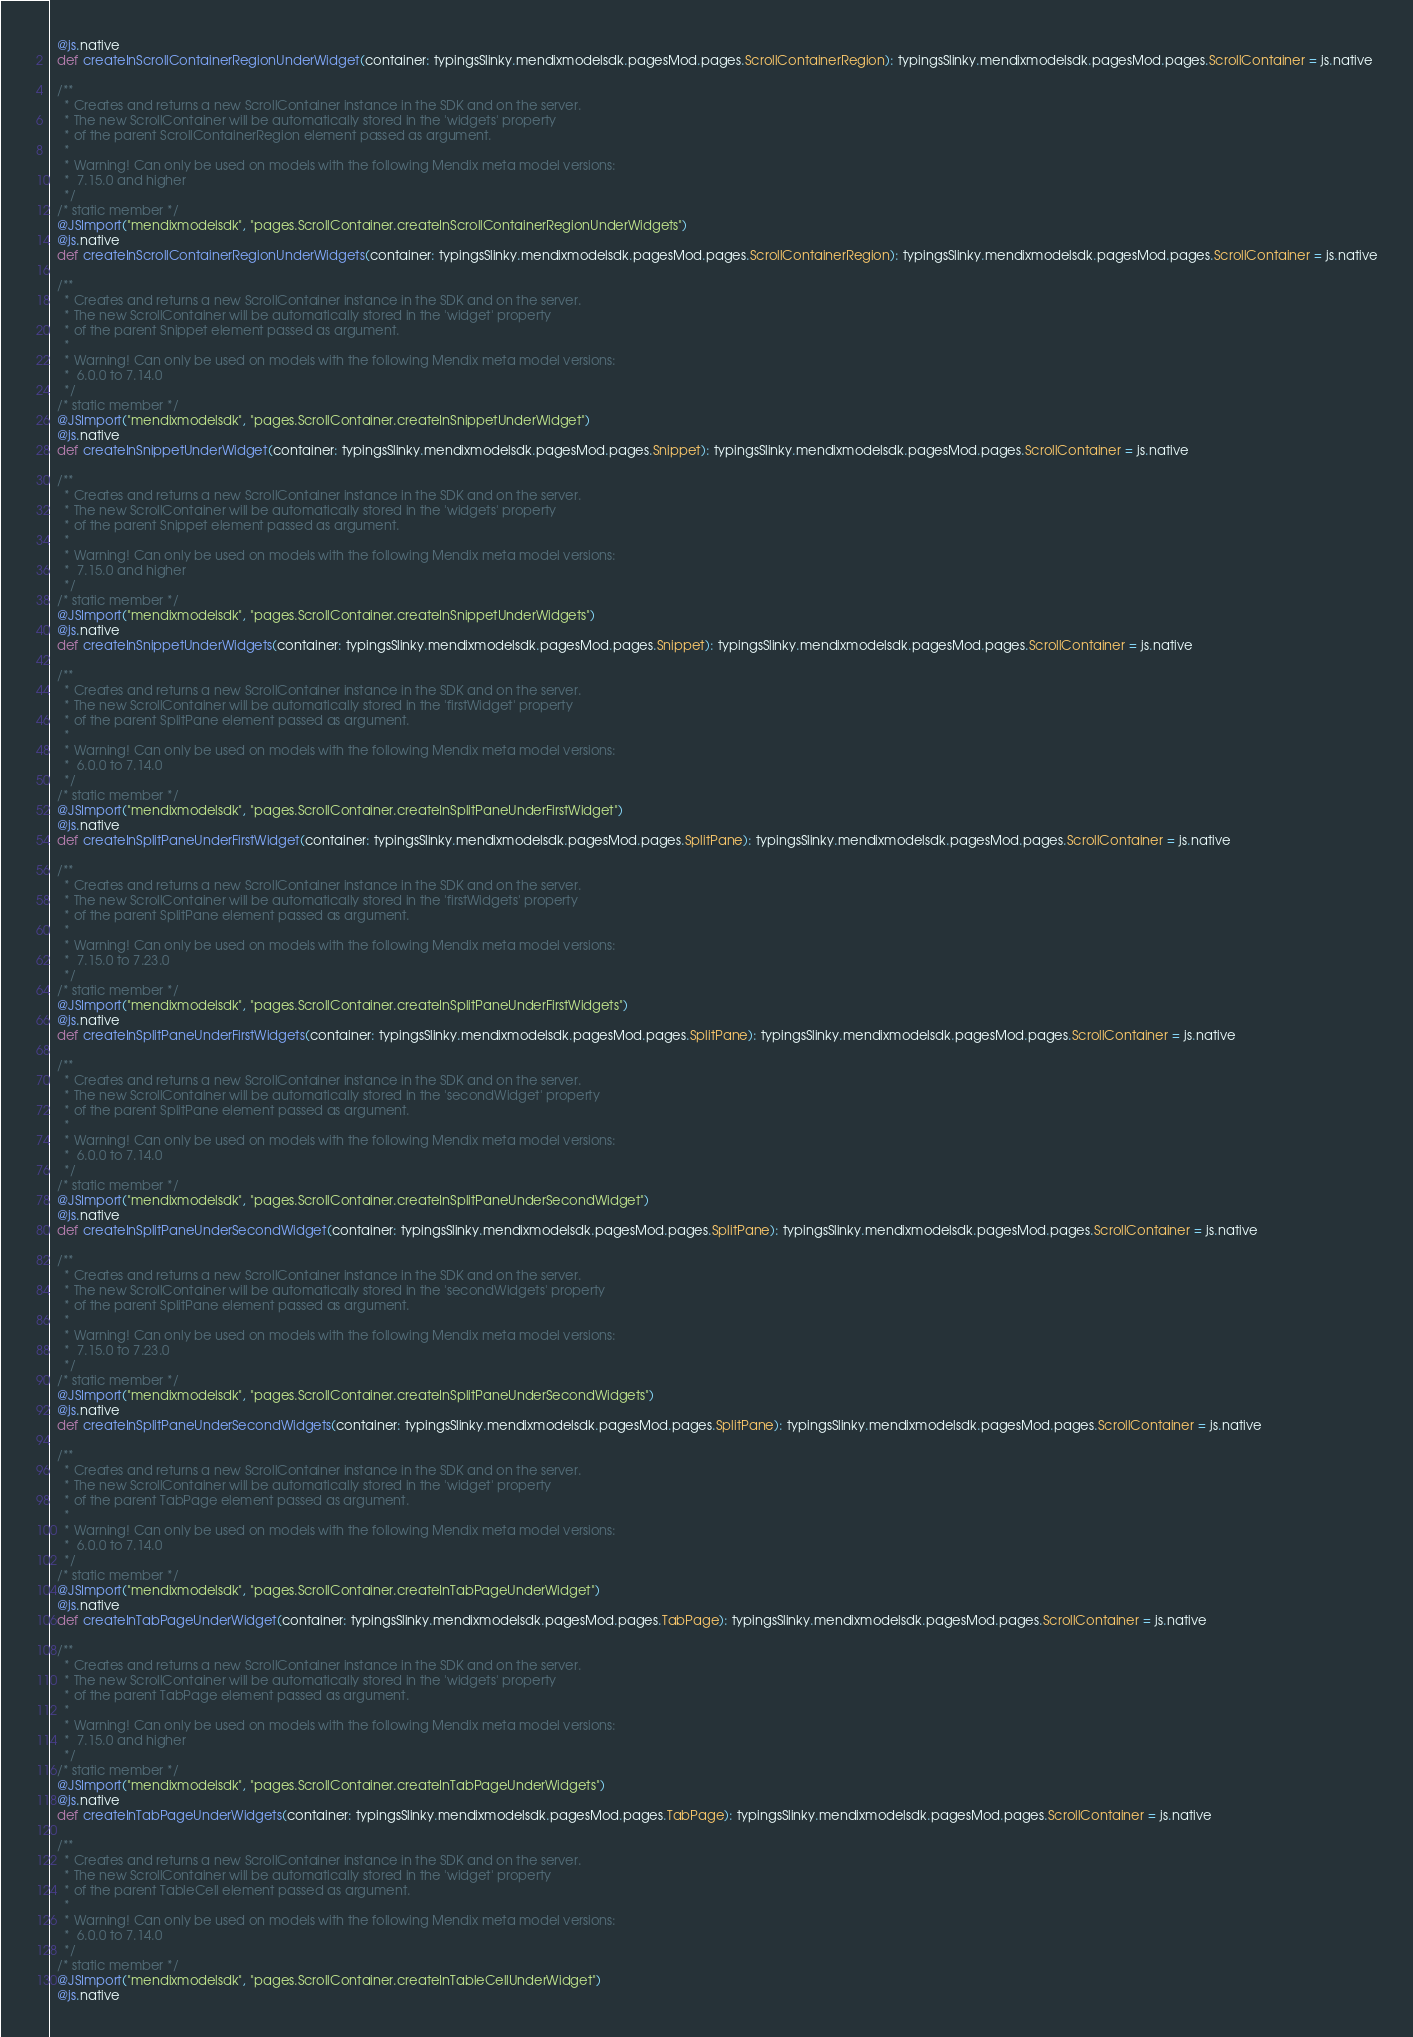Convert code to text. <code><loc_0><loc_0><loc_500><loc_500><_Scala_>  @js.native
  def createInScrollContainerRegionUnderWidget(container: typingsSlinky.mendixmodelsdk.pagesMod.pages.ScrollContainerRegion): typingsSlinky.mendixmodelsdk.pagesMod.pages.ScrollContainer = js.native
  
  /**
    * Creates and returns a new ScrollContainer instance in the SDK and on the server.
    * The new ScrollContainer will be automatically stored in the 'widgets' property
    * of the parent ScrollContainerRegion element passed as argument.
    *
    * Warning! Can only be used on models with the following Mendix meta model versions:
    *  7.15.0 and higher
    */
  /* static member */
  @JSImport("mendixmodelsdk", "pages.ScrollContainer.createInScrollContainerRegionUnderWidgets")
  @js.native
  def createInScrollContainerRegionUnderWidgets(container: typingsSlinky.mendixmodelsdk.pagesMod.pages.ScrollContainerRegion): typingsSlinky.mendixmodelsdk.pagesMod.pages.ScrollContainer = js.native
  
  /**
    * Creates and returns a new ScrollContainer instance in the SDK and on the server.
    * The new ScrollContainer will be automatically stored in the 'widget' property
    * of the parent Snippet element passed as argument.
    *
    * Warning! Can only be used on models with the following Mendix meta model versions:
    *  6.0.0 to 7.14.0
    */
  /* static member */
  @JSImport("mendixmodelsdk", "pages.ScrollContainer.createInSnippetUnderWidget")
  @js.native
  def createInSnippetUnderWidget(container: typingsSlinky.mendixmodelsdk.pagesMod.pages.Snippet): typingsSlinky.mendixmodelsdk.pagesMod.pages.ScrollContainer = js.native
  
  /**
    * Creates and returns a new ScrollContainer instance in the SDK and on the server.
    * The new ScrollContainer will be automatically stored in the 'widgets' property
    * of the parent Snippet element passed as argument.
    *
    * Warning! Can only be used on models with the following Mendix meta model versions:
    *  7.15.0 and higher
    */
  /* static member */
  @JSImport("mendixmodelsdk", "pages.ScrollContainer.createInSnippetUnderWidgets")
  @js.native
  def createInSnippetUnderWidgets(container: typingsSlinky.mendixmodelsdk.pagesMod.pages.Snippet): typingsSlinky.mendixmodelsdk.pagesMod.pages.ScrollContainer = js.native
  
  /**
    * Creates and returns a new ScrollContainer instance in the SDK and on the server.
    * The new ScrollContainer will be automatically stored in the 'firstWidget' property
    * of the parent SplitPane element passed as argument.
    *
    * Warning! Can only be used on models with the following Mendix meta model versions:
    *  6.0.0 to 7.14.0
    */
  /* static member */
  @JSImport("mendixmodelsdk", "pages.ScrollContainer.createInSplitPaneUnderFirstWidget")
  @js.native
  def createInSplitPaneUnderFirstWidget(container: typingsSlinky.mendixmodelsdk.pagesMod.pages.SplitPane): typingsSlinky.mendixmodelsdk.pagesMod.pages.ScrollContainer = js.native
  
  /**
    * Creates and returns a new ScrollContainer instance in the SDK and on the server.
    * The new ScrollContainer will be automatically stored in the 'firstWidgets' property
    * of the parent SplitPane element passed as argument.
    *
    * Warning! Can only be used on models with the following Mendix meta model versions:
    *  7.15.0 to 7.23.0
    */
  /* static member */
  @JSImport("mendixmodelsdk", "pages.ScrollContainer.createInSplitPaneUnderFirstWidgets")
  @js.native
  def createInSplitPaneUnderFirstWidgets(container: typingsSlinky.mendixmodelsdk.pagesMod.pages.SplitPane): typingsSlinky.mendixmodelsdk.pagesMod.pages.ScrollContainer = js.native
  
  /**
    * Creates and returns a new ScrollContainer instance in the SDK and on the server.
    * The new ScrollContainer will be automatically stored in the 'secondWidget' property
    * of the parent SplitPane element passed as argument.
    *
    * Warning! Can only be used on models with the following Mendix meta model versions:
    *  6.0.0 to 7.14.0
    */
  /* static member */
  @JSImport("mendixmodelsdk", "pages.ScrollContainer.createInSplitPaneUnderSecondWidget")
  @js.native
  def createInSplitPaneUnderSecondWidget(container: typingsSlinky.mendixmodelsdk.pagesMod.pages.SplitPane): typingsSlinky.mendixmodelsdk.pagesMod.pages.ScrollContainer = js.native
  
  /**
    * Creates and returns a new ScrollContainer instance in the SDK and on the server.
    * The new ScrollContainer will be automatically stored in the 'secondWidgets' property
    * of the parent SplitPane element passed as argument.
    *
    * Warning! Can only be used on models with the following Mendix meta model versions:
    *  7.15.0 to 7.23.0
    */
  /* static member */
  @JSImport("mendixmodelsdk", "pages.ScrollContainer.createInSplitPaneUnderSecondWidgets")
  @js.native
  def createInSplitPaneUnderSecondWidgets(container: typingsSlinky.mendixmodelsdk.pagesMod.pages.SplitPane): typingsSlinky.mendixmodelsdk.pagesMod.pages.ScrollContainer = js.native
  
  /**
    * Creates and returns a new ScrollContainer instance in the SDK and on the server.
    * The new ScrollContainer will be automatically stored in the 'widget' property
    * of the parent TabPage element passed as argument.
    *
    * Warning! Can only be used on models with the following Mendix meta model versions:
    *  6.0.0 to 7.14.0
    */
  /* static member */
  @JSImport("mendixmodelsdk", "pages.ScrollContainer.createInTabPageUnderWidget")
  @js.native
  def createInTabPageUnderWidget(container: typingsSlinky.mendixmodelsdk.pagesMod.pages.TabPage): typingsSlinky.mendixmodelsdk.pagesMod.pages.ScrollContainer = js.native
  
  /**
    * Creates and returns a new ScrollContainer instance in the SDK and on the server.
    * The new ScrollContainer will be automatically stored in the 'widgets' property
    * of the parent TabPage element passed as argument.
    *
    * Warning! Can only be used on models with the following Mendix meta model versions:
    *  7.15.0 and higher
    */
  /* static member */
  @JSImport("mendixmodelsdk", "pages.ScrollContainer.createInTabPageUnderWidgets")
  @js.native
  def createInTabPageUnderWidgets(container: typingsSlinky.mendixmodelsdk.pagesMod.pages.TabPage): typingsSlinky.mendixmodelsdk.pagesMod.pages.ScrollContainer = js.native
  
  /**
    * Creates and returns a new ScrollContainer instance in the SDK and on the server.
    * The new ScrollContainer will be automatically stored in the 'widget' property
    * of the parent TableCell element passed as argument.
    *
    * Warning! Can only be used on models with the following Mendix meta model versions:
    *  6.0.0 to 7.14.0
    */
  /* static member */
  @JSImport("mendixmodelsdk", "pages.ScrollContainer.createInTableCellUnderWidget")
  @js.native</code> 